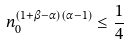Convert formula to latex. <formula><loc_0><loc_0><loc_500><loc_500>n _ { 0 } ^ { ( 1 + \beta - \alpha ) ( \alpha - 1 ) } \leq \frac { 1 } { 4 }</formula> 